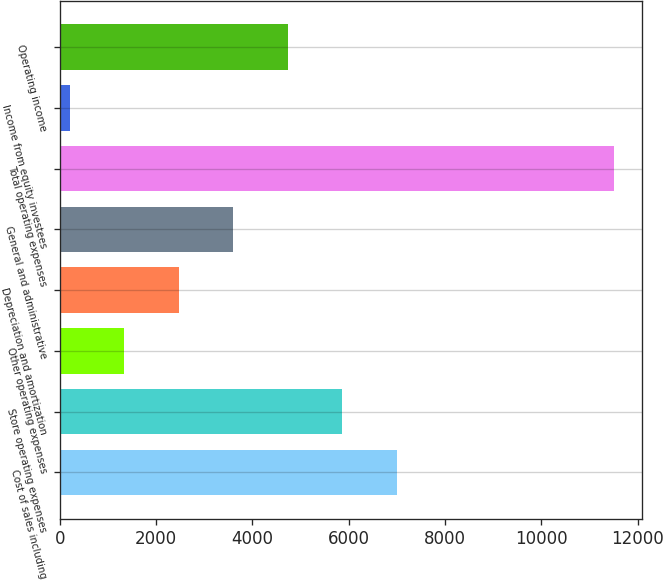Convert chart. <chart><loc_0><loc_0><loc_500><loc_500><bar_chart><fcel>Cost of sales including<fcel>Store operating expenses<fcel>Other operating expenses<fcel>Depreciation and amortization<fcel>General and administrative<fcel>Total operating expenses<fcel>Income from equity investees<fcel>Operating income<nl><fcel>6991.96<fcel>5861.75<fcel>1340.91<fcel>2471.12<fcel>3601.33<fcel>11512.8<fcel>210.7<fcel>4731.54<nl></chart> 